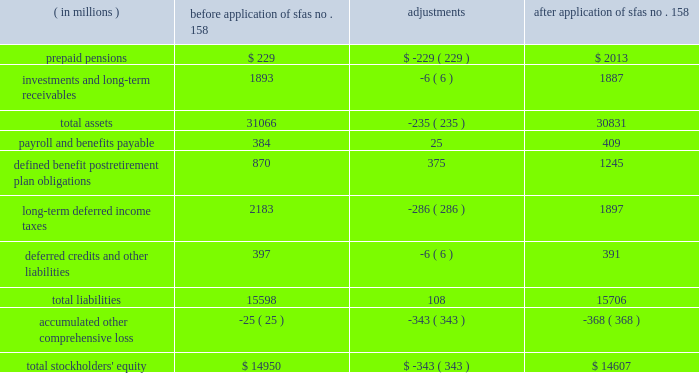The table illustrates the incremental effect of applying sfas no .
158 on individual line items of the balance sheet as of december 31 , 2006 .
Before after application of application of ( in millions ) sfas no .
158 adjustments sfas no .
158 .
Sab no .
108 2013 in september 2006 , the securities and exchange commission issued staff accounting bulletin ( 2018 2018sab 2019 2019 ) no .
108 , 2018 2018financial statements 2013 considering the effects of prior year misstatements when quantifying misstatements in current year financial statements . 2019 2019 sab no .
108 addresses how a registrant should quantify the effect of an error in the financial statements for purposes of assessing materiality and requires that the effect be computed using both the current year income statement perspective ( 2018 2018rollover 2019 2019 ) and the year end balance sheet perspective ( 2018 2018iron curtain 2019 2019 ) methods for fiscal years ending after november 15 , 2006 .
If a change in the method of quantifying errors is required under sab no .
108 , this represents a change in accounting policy ; therefore , if the use of both methods results in a larger , material misstatement than the previously applied method , the financial statements must be adjusted .
Sab no .
108 allows the cumulative effect of such adjustments to be made to opening retained earnings upon adoption .
Marathon adopted sab no .
108 for the year ended december 31 , 2006 , and adoption did not have an effect on marathon 2019s consolidated results of operations , financial position or cash flows .
Eitf issue no .
06-03 2013 in june 2006 , the fasb ratified the consensus reached by the eitf regarding issue no .
06-03 , 2018 2018how taxes collected from customers and remitted to governmental authorities should be presented in the income statement ( that is , gross versus net presentation ) . 2019 2019 included in the scope of this issue are any taxes assessed by a governmental authority that are imposed on and concurrent with a specific revenue-producing transaction between a seller and a customer .
The eitf concluded that the presentation of such taxes on a gross basis ( included in revenues and costs ) or a net basis ( excluded from revenues ) is an accounting policy decision that should be disclosed pursuant to accounting principles board ( 2018 2018apb 2019 2019 ) opinion no .
22 , 2018 2018disclosure of accounting policies . 2019 2019 in addition , the amounts of such taxes reported on a gross basis must be disclosed if those tax amounts are significant .
The policy disclosures required by this consensus are included in note 1 under the heading 2018 2018consumer excise taxes 2019 2019 and the taxes reported on a gross basis are presented separately as consumer excise taxes in the consolidated statements of income .
Eitf issue no .
04-13 2013 in september 2005 , the fasb ratified the consensus reached by the eitf on issue no .
04-13 , 2018 2018accounting for purchases and sales of inventory with the same counterparty . 2019 2019 the consensus establishes the circumstances under which two or more inventory purchase and sale transactions with the same counterparty should be recognized at fair value or viewed as a single exchange transaction subject to apb opinion no .
29 , 2018 2018accounting for nonmonetary transactions . 2019 2019 in general , two or more transactions with the same counterparty must be combined for purposes of applying apb opinion no .
29 if they are entered into in contemplation of each other .
The purchase and sale transactions may be pursuant to a single contractual arrangement or separate contractual arrangements and the inventory purchased or sold may be in the form of raw materials , work-in-process or finished goods .
Effective april 1 , 2006 , marathon adopted the provisions of eitf issue no .
04-13 prospectively .
Eitf issue no .
04-13 changes the accounting for matching buy/sell arrangements that are entered into or modified on or after april 1 , 2006 ( except for those accounted for as derivative instruments , which are discussed below ) .
In a typical matching buy/sell transaction , marathon enters into a contract to sell a particular quantity and quality of crude oil or refined product at a specified location and date to a particular counterparty and simultaneously agrees to buy a particular quantity and quality of the same commodity at a specified location on the same or another specified date from the same counterparty .
Prior to adoption of eitf issue no .
04-13 , marathon recorded such matching buy/sell transactions in both revenues and cost of revenues as separate sale and purchase transactions .
Upon adoption , these transactions are accounted for as exchanges of inventory .
The scope of eitf issue no .
04-13 excludes matching buy/sell arrangements that are accounted for as derivative instruments .
A portion of marathon 2019s matching buy/sell transactions are 2018 2018nontraditional derivative instruments , 2019 2019 which are discussed in note 1 .
Although the accounting for nontraditional derivative instruments is outside the scope of eitf issue no .
04-13 , the conclusions reached in that consensus caused marathon to reconsider the guidance in eitf issue no .
03-11 , 2018 2018reporting realized gains and losses on derivative instruments that are subject to fasb statement no .
133 and not 2018 2018held for trading purposes 2019 2019 as defined in issue no .
02-3 . 2019 2019 as a result , effective for contracts entered into or modified on or after april 1 , 2006 , the effects of matching buy/sell arrangements accounted for as nontraditional derivative instruments are recognized on a net basis in net income and are classified as cost of revenues .
Prior to this change , marathon recorded these transactions in both revenues and cost of revenues as separate sale and purchase transactions .
This change in accounting principle is being applied on a prospective basis because it is impracticable to apply the change on a retrospective basis. .
What was the percentage change in total stockholders' equity due to the adoption of fas 158? 
Computations: (-343 / 14950)
Answer: -0.02294. 